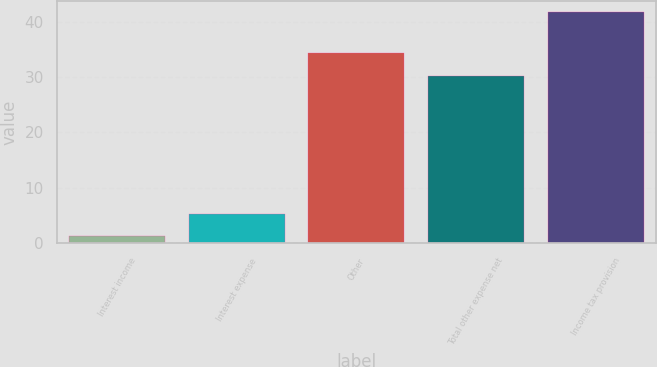Convert chart. <chart><loc_0><loc_0><loc_500><loc_500><bar_chart><fcel>Interest income<fcel>Interest expense<fcel>Other<fcel>Total other expense net<fcel>Income tax provision<nl><fcel>1.3<fcel>5.34<fcel>34.24<fcel>30.2<fcel>41.7<nl></chart> 